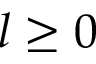<formula> <loc_0><loc_0><loc_500><loc_500>l \geq 0</formula> 